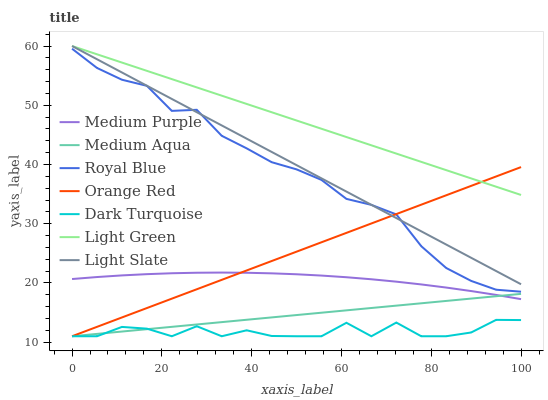Does Dark Turquoise have the minimum area under the curve?
Answer yes or no. Yes. Does Light Green have the maximum area under the curve?
Answer yes or no. Yes. Does Medium Purple have the minimum area under the curve?
Answer yes or no. No. Does Medium Purple have the maximum area under the curve?
Answer yes or no. No. Is Light Green the smoothest?
Answer yes or no. Yes. Is Dark Turquoise the roughest?
Answer yes or no. Yes. Is Medium Purple the smoothest?
Answer yes or no. No. Is Medium Purple the roughest?
Answer yes or no. No. Does Dark Turquoise have the lowest value?
Answer yes or no. Yes. Does Medium Purple have the lowest value?
Answer yes or no. No. Does Light Green have the highest value?
Answer yes or no. Yes. Does Medium Purple have the highest value?
Answer yes or no. No. Is Dark Turquoise less than Royal Blue?
Answer yes or no. Yes. Is Medium Purple greater than Dark Turquoise?
Answer yes or no. Yes. Does Light Green intersect Light Slate?
Answer yes or no. Yes. Is Light Green less than Light Slate?
Answer yes or no. No. Is Light Green greater than Light Slate?
Answer yes or no. No. Does Dark Turquoise intersect Royal Blue?
Answer yes or no. No. 